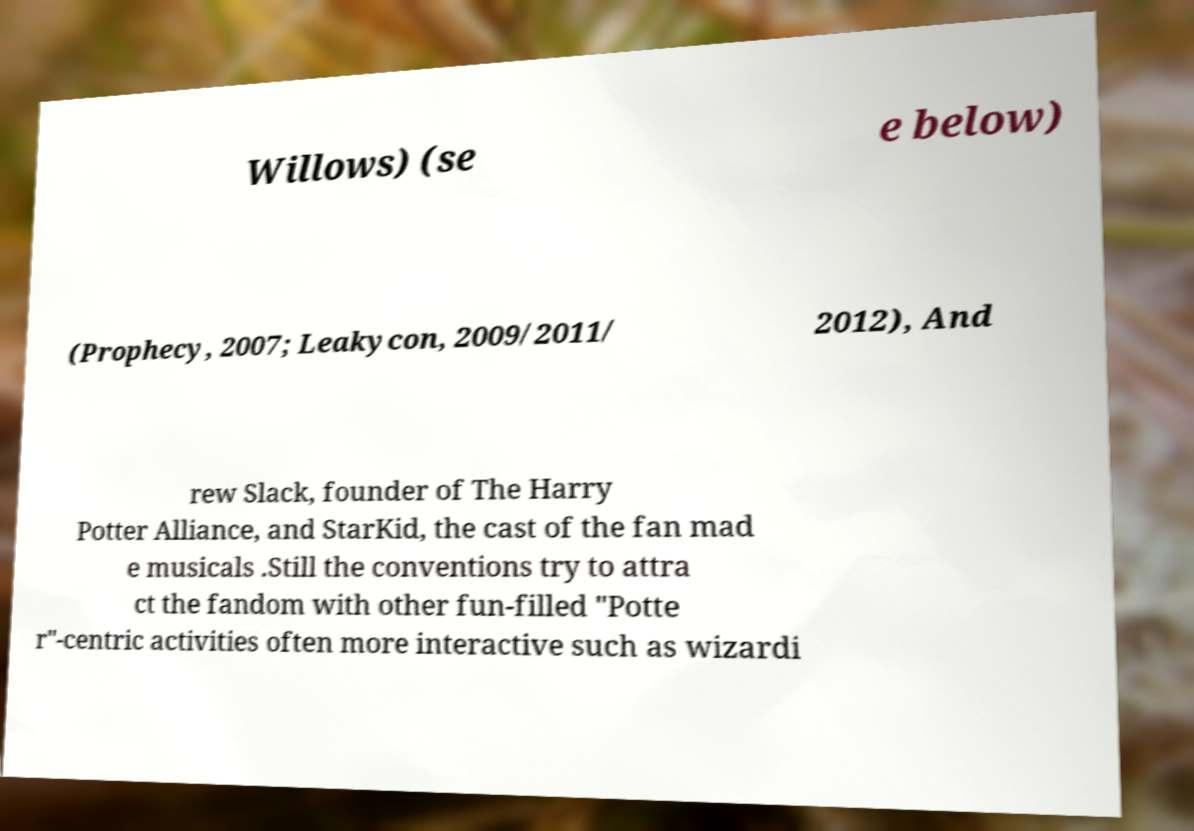What messages or text are displayed in this image? I need them in a readable, typed format. Willows) (se e below) (Prophecy, 2007; Leakycon, 2009/2011/ 2012), And rew Slack, founder of The Harry Potter Alliance, and StarKid, the cast of the fan mad e musicals .Still the conventions try to attra ct the fandom with other fun-filled "Potte r"-centric activities often more interactive such as wizardi 